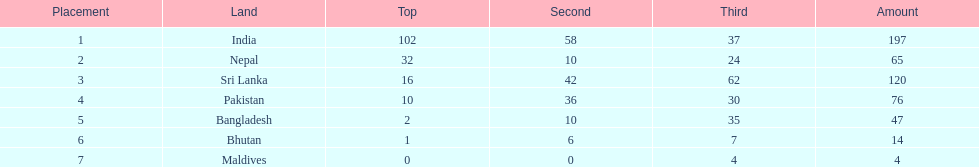How many gold medals did india win? 102. 